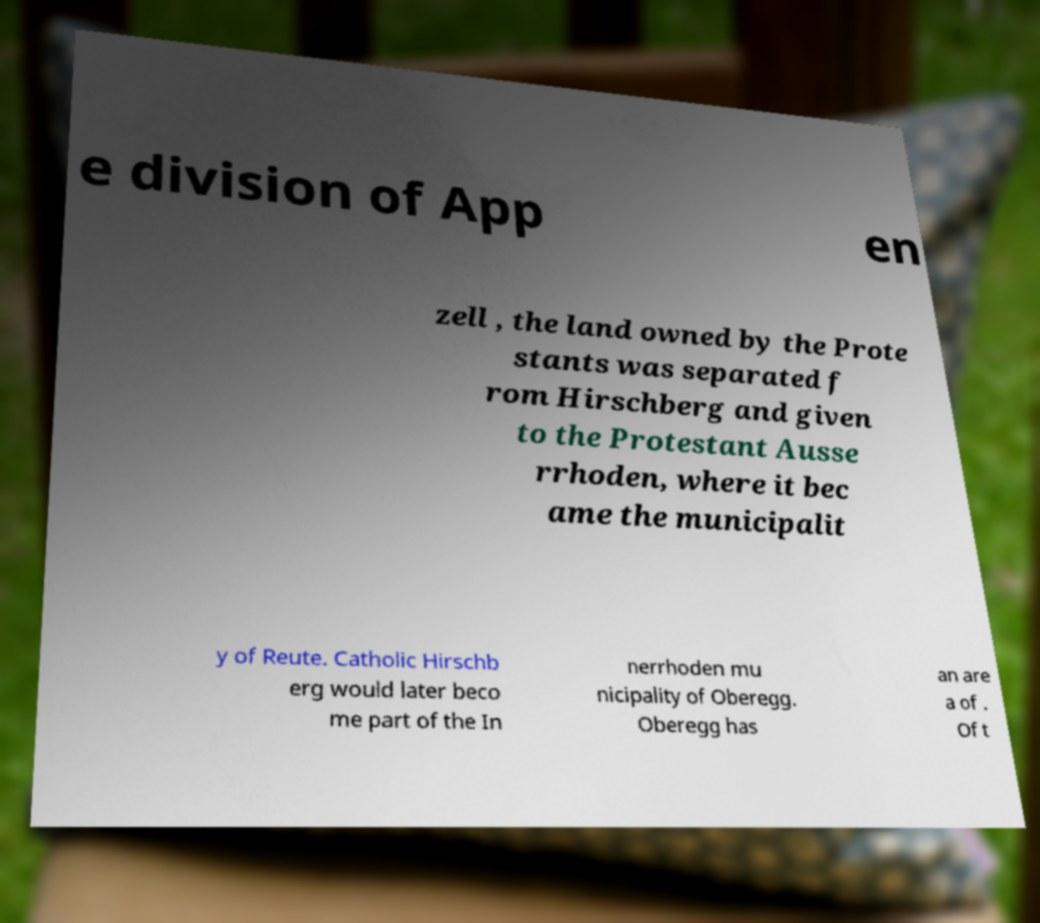Could you assist in decoding the text presented in this image and type it out clearly? e division of App en zell , the land owned by the Prote stants was separated f rom Hirschberg and given to the Protestant Ausse rrhoden, where it bec ame the municipalit y of Reute. Catholic Hirschb erg would later beco me part of the In nerrhoden mu nicipality of Oberegg. Oberegg has an are a of . Of t 